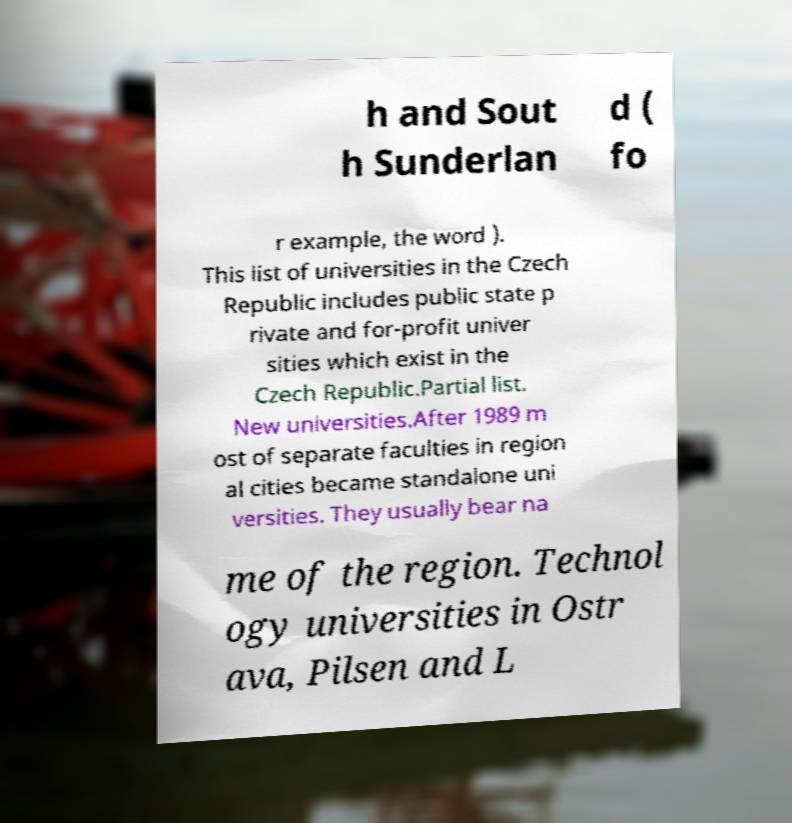Please identify and transcribe the text found in this image. h and Sout h Sunderlan d ( fo r example, the word ). This list of universities in the Czech Republic includes public state p rivate and for-profit univer sities which exist in the Czech Republic.Partial list. New universities.After 1989 m ost of separate faculties in region al cities became standalone uni versities. They usually bear na me of the region. Technol ogy universities in Ostr ava, Pilsen and L 